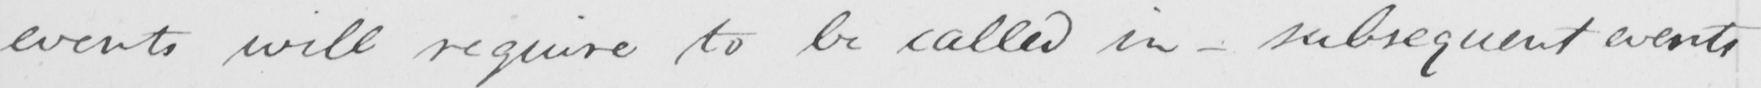What does this handwritten line say? events will require to be called in  _  subsequent events 